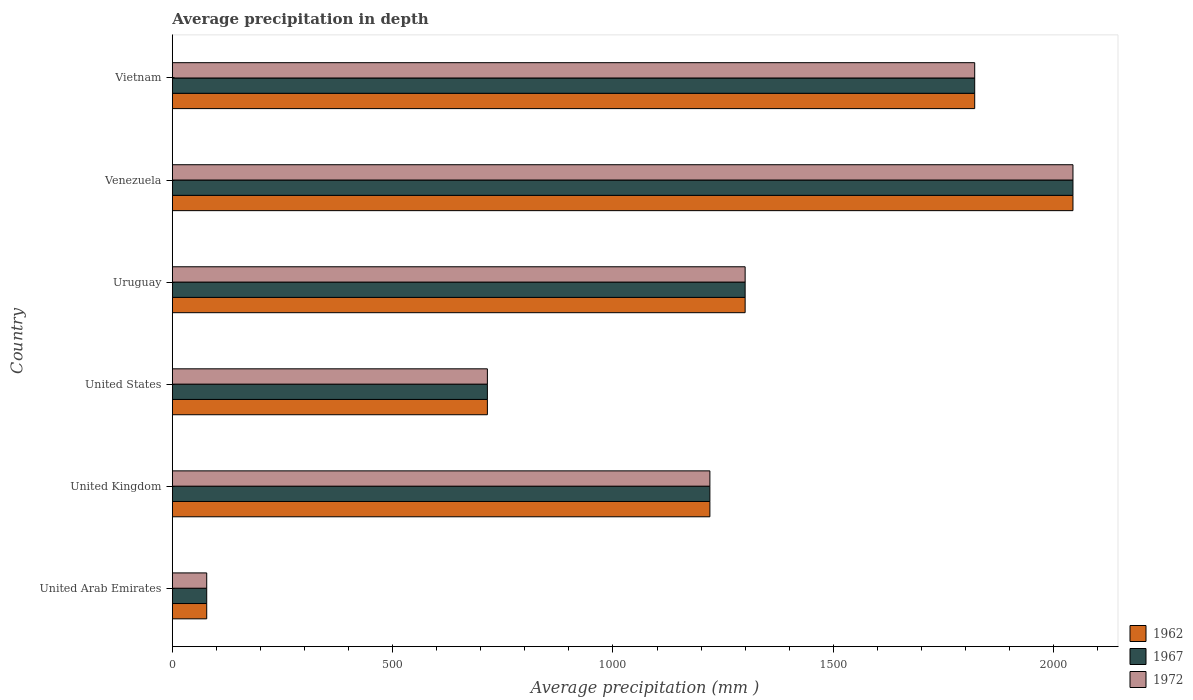How many different coloured bars are there?
Offer a terse response. 3. How many groups of bars are there?
Your response must be concise. 6. Are the number of bars on each tick of the Y-axis equal?
Provide a succinct answer. Yes. How many bars are there on the 4th tick from the top?
Your response must be concise. 3. What is the label of the 1st group of bars from the top?
Ensure brevity in your answer.  Vietnam. In how many cases, is the number of bars for a given country not equal to the number of legend labels?
Your answer should be very brief. 0. What is the average precipitation in 1962 in United Arab Emirates?
Offer a very short reply. 78. Across all countries, what is the maximum average precipitation in 1972?
Provide a succinct answer. 2044. Across all countries, what is the minimum average precipitation in 1962?
Provide a short and direct response. 78. In which country was the average precipitation in 1967 maximum?
Make the answer very short. Venezuela. In which country was the average precipitation in 1967 minimum?
Offer a terse response. United Arab Emirates. What is the total average precipitation in 1972 in the graph?
Your answer should be very brief. 7178. What is the difference between the average precipitation in 1972 in United Kingdom and that in Venezuela?
Provide a short and direct response. -824. What is the difference between the average precipitation in 1967 in United States and the average precipitation in 1962 in Uruguay?
Your answer should be very brief. -585. What is the average average precipitation in 1967 per country?
Provide a succinct answer. 1196.33. What is the difference between the average precipitation in 1967 and average precipitation in 1972 in United States?
Keep it short and to the point. 0. In how many countries, is the average precipitation in 1972 greater than 600 mm?
Your answer should be very brief. 5. What is the ratio of the average precipitation in 1967 in United Kingdom to that in United States?
Provide a succinct answer. 1.71. Is the difference between the average precipitation in 1967 in United States and Uruguay greater than the difference between the average precipitation in 1972 in United States and Uruguay?
Give a very brief answer. No. What is the difference between the highest and the second highest average precipitation in 1967?
Provide a succinct answer. 223. What is the difference between the highest and the lowest average precipitation in 1962?
Your answer should be compact. 1966. What does the 2nd bar from the bottom in United Kingdom represents?
Give a very brief answer. 1967. Are all the bars in the graph horizontal?
Offer a very short reply. Yes. What is the difference between two consecutive major ticks on the X-axis?
Give a very brief answer. 500. Are the values on the major ticks of X-axis written in scientific E-notation?
Your answer should be compact. No. Where does the legend appear in the graph?
Provide a short and direct response. Bottom right. How many legend labels are there?
Your answer should be compact. 3. What is the title of the graph?
Your answer should be compact. Average precipitation in depth. What is the label or title of the X-axis?
Provide a short and direct response. Average precipitation (mm ). What is the Average precipitation (mm ) in 1962 in United Arab Emirates?
Offer a very short reply. 78. What is the Average precipitation (mm ) of 1972 in United Arab Emirates?
Your response must be concise. 78. What is the Average precipitation (mm ) in 1962 in United Kingdom?
Make the answer very short. 1220. What is the Average precipitation (mm ) in 1967 in United Kingdom?
Your answer should be very brief. 1220. What is the Average precipitation (mm ) of 1972 in United Kingdom?
Offer a terse response. 1220. What is the Average precipitation (mm ) in 1962 in United States?
Offer a terse response. 715. What is the Average precipitation (mm ) in 1967 in United States?
Provide a succinct answer. 715. What is the Average precipitation (mm ) in 1972 in United States?
Your answer should be very brief. 715. What is the Average precipitation (mm ) of 1962 in Uruguay?
Your response must be concise. 1300. What is the Average precipitation (mm ) of 1967 in Uruguay?
Your response must be concise. 1300. What is the Average precipitation (mm ) in 1972 in Uruguay?
Make the answer very short. 1300. What is the Average precipitation (mm ) in 1962 in Venezuela?
Your answer should be compact. 2044. What is the Average precipitation (mm ) in 1967 in Venezuela?
Ensure brevity in your answer.  2044. What is the Average precipitation (mm ) in 1972 in Venezuela?
Provide a succinct answer. 2044. What is the Average precipitation (mm ) of 1962 in Vietnam?
Offer a terse response. 1821. What is the Average precipitation (mm ) in 1967 in Vietnam?
Offer a very short reply. 1821. What is the Average precipitation (mm ) in 1972 in Vietnam?
Ensure brevity in your answer.  1821. Across all countries, what is the maximum Average precipitation (mm ) of 1962?
Your response must be concise. 2044. Across all countries, what is the maximum Average precipitation (mm ) of 1967?
Ensure brevity in your answer.  2044. Across all countries, what is the maximum Average precipitation (mm ) in 1972?
Provide a succinct answer. 2044. Across all countries, what is the minimum Average precipitation (mm ) of 1962?
Provide a short and direct response. 78. Across all countries, what is the minimum Average precipitation (mm ) in 1972?
Offer a terse response. 78. What is the total Average precipitation (mm ) in 1962 in the graph?
Provide a succinct answer. 7178. What is the total Average precipitation (mm ) of 1967 in the graph?
Your answer should be very brief. 7178. What is the total Average precipitation (mm ) in 1972 in the graph?
Provide a succinct answer. 7178. What is the difference between the Average precipitation (mm ) of 1962 in United Arab Emirates and that in United Kingdom?
Give a very brief answer. -1142. What is the difference between the Average precipitation (mm ) of 1967 in United Arab Emirates and that in United Kingdom?
Keep it short and to the point. -1142. What is the difference between the Average precipitation (mm ) of 1972 in United Arab Emirates and that in United Kingdom?
Offer a very short reply. -1142. What is the difference between the Average precipitation (mm ) in 1962 in United Arab Emirates and that in United States?
Ensure brevity in your answer.  -637. What is the difference between the Average precipitation (mm ) of 1967 in United Arab Emirates and that in United States?
Keep it short and to the point. -637. What is the difference between the Average precipitation (mm ) of 1972 in United Arab Emirates and that in United States?
Your response must be concise. -637. What is the difference between the Average precipitation (mm ) in 1962 in United Arab Emirates and that in Uruguay?
Your response must be concise. -1222. What is the difference between the Average precipitation (mm ) of 1967 in United Arab Emirates and that in Uruguay?
Make the answer very short. -1222. What is the difference between the Average precipitation (mm ) of 1972 in United Arab Emirates and that in Uruguay?
Give a very brief answer. -1222. What is the difference between the Average precipitation (mm ) of 1962 in United Arab Emirates and that in Venezuela?
Keep it short and to the point. -1966. What is the difference between the Average precipitation (mm ) of 1967 in United Arab Emirates and that in Venezuela?
Provide a short and direct response. -1966. What is the difference between the Average precipitation (mm ) in 1972 in United Arab Emirates and that in Venezuela?
Your answer should be compact. -1966. What is the difference between the Average precipitation (mm ) in 1962 in United Arab Emirates and that in Vietnam?
Keep it short and to the point. -1743. What is the difference between the Average precipitation (mm ) of 1967 in United Arab Emirates and that in Vietnam?
Your answer should be very brief. -1743. What is the difference between the Average precipitation (mm ) of 1972 in United Arab Emirates and that in Vietnam?
Ensure brevity in your answer.  -1743. What is the difference between the Average precipitation (mm ) of 1962 in United Kingdom and that in United States?
Make the answer very short. 505. What is the difference between the Average precipitation (mm ) of 1967 in United Kingdom and that in United States?
Offer a very short reply. 505. What is the difference between the Average precipitation (mm ) in 1972 in United Kingdom and that in United States?
Ensure brevity in your answer.  505. What is the difference between the Average precipitation (mm ) of 1962 in United Kingdom and that in Uruguay?
Give a very brief answer. -80. What is the difference between the Average precipitation (mm ) in 1967 in United Kingdom and that in Uruguay?
Provide a succinct answer. -80. What is the difference between the Average precipitation (mm ) of 1972 in United Kingdom and that in Uruguay?
Provide a short and direct response. -80. What is the difference between the Average precipitation (mm ) of 1962 in United Kingdom and that in Venezuela?
Provide a short and direct response. -824. What is the difference between the Average precipitation (mm ) of 1967 in United Kingdom and that in Venezuela?
Give a very brief answer. -824. What is the difference between the Average precipitation (mm ) of 1972 in United Kingdom and that in Venezuela?
Provide a short and direct response. -824. What is the difference between the Average precipitation (mm ) in 1962 in United Kingdom and that in Vietnam?
Your response must be concise. -601. What is the difference between the Average precipitation (mm ) in 1967 in United Kingdom and that in Vietnam?
Offer a terse response. -601. What is the difference between the Average precipitation (mm ) of 1972 in United Kingdom and that in Vietnam?
Your answer should be very brief. -601. What is the difference between the Average precipitation (mm ) of 1962 in United States and that in Uruguay?
Your response must be concise. -585. What is the difference between the Average precipitation (mm ) in 1967 in United States and that in Uruguay?
Offer a very short reply. -585. What is the difference between the Average precipitation (mm ) of 1972 in United States and that in Uruguay?
Your answer should be very brief. -585. What is the difference between the Average precipitation (mm ) in 1962 in United States and that in Venezuela?
Provide a short and direct response. -1329. What is the difference between the Average precipitation (mm ) of 1967 in United States and that in Venezuela?
Make the answer very short. -1329. What is the difference between the Average precipitation (mm ) in 1972 in United States and that in Venezuela?
Your answer should be very brief. -1329. What is the difference between the Average precipitation (mm ) of 1962 in United States and that in Vietnam?
Offer a terse response. -1106. What is the difference between the Average precipitation (mm ) in 1967 in United States and that in Vietnam?
Make the answer very short. -1106. What is the difference between the Average precipitation (mm ) of 1972 in United States and that in Vietnam?
Provide a short and direct response. -1106. What is the difference between the Average precipitation (mm ) in 1962 in Uruguay and that in Venezuela?
Ensure brevity in your answer.  -744. What is the difference between the Average precipitation (mm ) in 1967 in Uruguay and that in Venezuela?
Ensure brevity in your answer.  -744. What is the difference between the Average precipitation (mm ) in 1972 in Uruguay and that in Venezuela?
Ensure brevity in your answer.  -744. What is the difference between the Average precipitation (mm ) of 1962 in Uruguay and that in Vietnam?
Provide a succinct answer. -521. What is the difference between the Average precipitation (mm ) of 1967 in Uruguay and that in Vietnam?
Keep it short and to the point. -521. What is the difference between the Average precipitation (mm ) of 1972 in Uruguay and that in Vietnam?
Your answer should be very brief. -521. What is the difference between the Average precipitation (mm ) of 1962 in Venezuela and that in Vietnam?
Offer a very short reply. 223. What is the difference between the Average precipitation (mm ) of 1967 in Venezuela and that in Vietnam?
Make the answer very short. 223. What is the difference between the Average precipitation (mm ) of 1972 in Venezuela and that in Vietnam?
Your response must be concise. 223. What is the difference between the Average precipitation (mm ) in 1962 in United Arab Emirates and the Average precipitation (mm ) in 1967 in United Kingdom?
Your response must be concise. -1142. What is the difference between the Average precipitation (mm ) of 1962 in United Arab Emirates and the Average precipitation (mm ) of 1972 in United Kingdom?
Keep it short and to the point. -1142. What is the difference between the Average precipitation (mm ) in 1967 in United Arab Emirates and the Average precipitation (mm ) in 1972 in United Kingdom?
Provide a short and direct response. -1142. What is the difference between the Average precipitation (mm ) in 1962 in United Arab Emirates and the Average precipitation (mm ) in 1967 in United States?
Your answer should be compact. -637. What is the difference between the Average precipitation (mm ) of 1962 in United Arab Emirates and the Average precipitation (mm ) of 1972 in United States?
Give a very brief answer. -637. What is the difference between the Average precipitation (mm ) in 1967 in United Arab Emirates and the Average precipitation (mm ) in 1972 in United States?
Make the answer very short. -637. What is the difference between the Average precipitation (mm ) in 1962 in United Arab Emirates and the Average precipitation (mm ) in 1967 in Uruguay?
Your answer should be very brief. -1222. What is the difference between the Average precipitation (mm ) in 1962 in United Arab Emirates and the Average precipitation (mm ) in 1972 in Uruguay?
Provide a succinct answer. -1222. What is the difference between the Average precipitation (mm ) in 1967 in United Arab Emirates and the Average precipitation (mm ) in 1972 in Uruguay?
Your answer should be compact. -1222. What is the difference between the Average precipitation (mm ) in 1962 in United Arab Emirates and the Average precipitation (mm ) in 1967 in Venezuela?
Your answer should be compact. -1966. What is the difference between the Average precipitation (mm ) in 1962 in United Arab Emirates and the Average precipitation (mm ) in 1972 in Venezuela?
Provide a short and direct response. -1966. What is the difference between the Average precipitation (mm ) of 1967 in United Arab Emirates and the Average precipitation (mm ) of 1972 in Venezuela?
Offer a very short reply. -1966. What is the difference between the Average precipitation (mm ) in 1962 in United Arab Emirates and the Average precipitation (mm ) in 1967 in Vietnam?
Make the answer very short. -1743. What is the difference between the Average precipitation (mm ) of 1962 in United Arab Emirates and the Average precipitation (mm ) of 1972 in Vietnam?
Make the answer very short. -1743. What is the difference between the Average precipitation (mm ) in 1967 in United Arab Emirates and the Average precipitation (mm ) in 1972 in Vietnam?
Make the answer very short. -1743. What is the difference between the Average precipitation (mm ) in 1962 in United Kingdom and the Average precipitation (mm ) in 1967 in United States?
Ensure brevity in your answer.  505. What is the difference between the Average precipitation (mm ) of 1962 in United Kingdom and the Average precipitation (mm ) of 1972 in United States?
Make the answer very short. 505. What is the difference between the Average precipitation (mm ) of 1967 in United Kingdom and the Average precipitation (mm ) of 1972 in United States?
Make the answer very short. 505. What is the difference between the Average precipitation (mm ) in 1962 in United Kingdom and the Average precipitation (mm ) in 1967 in Uruguay?
Your response must be concise. -80. What is the difference between the Average precipitation (mm ) in 1962 in United Kingdom and the Average precipitation (mm ) in 1972 in Uruguay?
Give a very brief answer. -80. What is the difference between the Average precipitation (mm ) of 1967 in United Kingdom and the Average precipitation (mm ) of 1972 in Uruguay?
Provide a short and direct response. -80. What is the difference between the Average precipitation (mm ) of 1962 in United Kingdom and the Average precipitation (mm ) of 1967 in Venezuela?
Ensure brevity in your answer.  -824. What is the difference between the Average precipitation (mm ) in 1962 in United Kingdom and the Average precipitation (mm ) in 1972 in Venezuela?
Keep it short and to the point. -824. What is the difference between the Average precipitation (mm ) in 1967 in United Kingdom and the Average precipitation (mm ) in 1972 in Venezuela?
Provide a short and direct response. -824. What is the difference between the Average precipitation (mm ) in 1962 in United Kingdom and the Average precipitation (mm ) in 1967 in Vietnam?
Make the answer very short. -601. What is the difference between the Average precipitation (mm ) in 1962 in United Kingdom and the Average precipitation (mm ) in 1972 in Vietnam?
Offer a very short reply. -601. What is the difference between the Average precipitation (mm ) in 1967 in United Kingdom and the Average precipitation (mm ) in 1972 in Vietnam?
Ensure brevity in your answer.  -601. What is the difference between the Average precipitation (mm ) of 1962 in United States and the Average precipitation (mm ) of 1967 in Uruguay?
Offer a terse response. -585. What is the difference between the Average precipitation (mm ) of 1962 in United States and the Average precipitation (mm ) of 1972 in Uruguay?
Provide a succinct answer. -585. What is the difference between the Average precipitation (mm ) in 1967 in United States and the Average precipitation (mm ) in 1972 in Uruguay?
Your response must be concise. -585. What is the difference between the Average precipitation (mm ) in 1962 in United States and the Average precipitation (mm ) in 1967 in Venezuela?
Give a very brief answer. -1329. What is the difference between the Average precipitation (mm ) in 1962 in United States and the Average precipitation (mm ) in 1972 in Venezuela?
Your answer should be very brief. -1329. What is the difference between the Average precipitation (mm ) in 1967 in United States and the Average precipitation (mm ) in 1972 in Venezuela?
Offer a very short reply. -1329. What is the difference between the Average precipitation (mm ) of 1962 in United States and the Average precipitation (mm ) of 1967 in Vietnam?
Ensure brevity in your answer.  -1106. What is the difference between the Average precipitation (mm ) in 1962 in United States and the Average precipitation (mm ) in 1972 in Vietnam?
Your response must be concise. -1106. What is the difference between the Average precipitation (mm ) of 1967 in United States and the Average precipitation (mm ) of 1972 in Vietnam?
Give a very brief answer. -1106. What is the difference between the Average precipitation (mm ) in 1962 in Uruguay and the Average precipitation (mm ) in 1967 in Venezuela?
Your answer should be compact. -744. What is the difference between the Average precipitation (mm ) in 1962 in Uruguay and the Average precipitation (mm ) in 1972 in Venezuela?
Your answer should be very brief. -744. What is the difference between the Average precipitation (mm ) of 1967 in Uruguay and the Average precipitation (mm ) of 1972 in Venezuela?
Provide a short and direct response. -744. What is the difference between the Average precipitation (mm ) of 1962 in Uruguay and the Average precipitation (mm ) of 1967 in Vietnam?
Offer a terse response. -521. What is the difference between the Average precipitation (mm ) in 1962 in Uruguay and the Average precipitation (mm ) in 1972 in Vietnam?
Keep it short and to the point. -521. What is the difference between the Average precipitation (mm ) in 1967 in Uruguay and the Average precipitation (mm ) in 1972 in Vietnam?
Provide a succinct answer. -521. What is the difference between the Average precipitation (mm ) in 1962 in Venezuela and the Average precipitation (mm ) in 1967 in Vietnam?
Your answer should be compact. 223. What is the difference between the Average precipitation (mm ) of 1962 in Venezuela and the Average precipitation (mm ) of 1972 in Vietnam?
Your answer should be very brief. 223. What is the difference between the Average precipitation (mm ) in 1967 in Venezuela and the Average precipitation (mm ) in 1972 in Vietnam?
Offer a very short reply. 223. What is the average Average precipitation (mm ) of 1962 per country?
Your response must be concise. 1196.33. What is the average Average precipitation (mm ) in 1967 per country?
Your response must be concise. 1196.33. What is the average Average precipitation (mm ) in 1972 per country?
Offer a terse response. 1196.33. What is the difference between the Average precipitation (mm ) in 1962 and Average precipitation (mm ) in 1972 in United Arab Emirates?
Offer a terse response. 0. What is the difference between the Average precipitation (mm ) in 1967 and Average precipitation (mm ) in 1972 in United Arab Emirates?
Give a very brief answer. 0. What is the difference between the Average precipitation (mm ) in 1962 and Average precipitation (mm ) in 1967 in United Kingdom?
Offer a terse response. 0. What is the difference between the Average precipitation (mm ) in 1967 and Average precipitation (mm ) in 1972 in United Kingdom?
Offer a terse response. 0. What is the difference between the Average precipitation (mm ) of 1967 and Average precipitation (mm ) of 1972 in United States?
Your answer should be compact. 0. What is the difference between the Average precipitation (mm ) in 1962 and Average precipitation (mm ) in 1967 in Uruguay?
Provide a short and direct response. 0. What is the difference between the Average precipitation (mm ) of 1967 and Average precipitation (mm ) of 1972 in Uruguay?
Make the answer very short. 0. What is the difference between the Average precipitation (mm ) of 1962 and Average precipitation (mm ) of 1967 in Venezuela?
Provide a short and direct response. 0. What is the difference between the Average precipitation (mm ) of 1967 and Average precipitation (mm ) of 1972 in Venezuela?
Your answer should be very brief. 0. What is the difference between the Average precipitation (mm ) in 1962 and Average precipitation (mm ) in 1967 in Vietnam?
Your answer should be compact. 0. What is the ratio of the Average precipitation (mm ) of 1962 in United Arab Emirates to that in United Kingdom?
Ensure brevity in your answer.  0.06. What is the ratio of the Average precipitation (mm ) in 1967 in United Arab Emirates to that in United Kingdom?
Provide a succinct answer. 0.06. What is the ratio of the Average precipitation (mm ) of 1972 in United Arab Emirates to that in United Kingdom?
Keep it short and to the point. 0.06. What is the ratio of the Average precipitation (mm ) in 1962 in United Arab Emirates to that in United States?
Ensure brevity in your answer.  0.11. What is the ratio of the Average precipitation (mm ) in 1967 in United Arab Emirates to that in United States?
Keep it short and to the point. 0.11. What is the ratio of the Average precipitation (mm ) of 1972 in United Arab Emirates to that in United States?
Your answer should be very brief. 0.11. What is the ratio of the Average precipitation (mm ) in 1962 in United Arab Emirates to that in Uruguay?
Make the answer very short. 0.06. What is the ratio of the Average precipitation (mm ) of 1967 in United Arab Emirates to that in Uruguay?
Your answer should be very brief. 0.06. What is the ratio of the Average precipitation (mm ) in 1962 in United Arab Emirates to that in Venezuela?
Your answer should be very brief. 0.04. What is the ratio of the Average precipitation (mm ) in 1967 in United Arab Emirates to that in Venezuela?
Provide a succinct answer. 0.04. What is the ratio of the Average precipitation (mm ) of 1972 in United Arab Emirates to that in Venezuela?
Provide a succinct answer. 0.04. What is the ratio of the Average precipitation (mm ) of 1962 in United Arab Emirates to that in Vietnam?
Ensure brevity in your answer.  0.04. What is the ratio of the Average precipitation (mm ) of 1967 in United Arab Emirates to that in Vietnam?
Ensure brevity in your answer.  0.04. What is the ratio of the Average precipitation (mm ) of 1972 in United Arab Emirates to that in Vietnam?
Your answer should be very brief. 0.04. What is the ratio of the Average precipitation (mm ) in 1962 in United Kingdom to that in United States?
Offer a terse response. 1.71. What is the ratio of the Average precipitation (mm ) of 1967 in United Kingdom to that in United States?
Ensure brevity in your answer.  1.71. What is the ratio of the Average precipitation (mm ) in 1972 in United Kingdom to that in United States?
Offer a terse response. 1.71. What is the ratio of the Average precipitation (mm ) in 1962 in United Kingdom to that in Uruguay?
Give a very brief answer. 0.94. What is the ratio of the Average precipitation (mm ) of 1967 in United Kingdom to that in Uruguay?
Provide a succinct answer. 0.94. What is the ratio of the Average precipitation (mm ) of 1972 in United Kingdom to that in Uruguay?
Provide a short and direct response. 0.94. What is the ratio of the Average precipitation (mm ) of 1962 in United Kingdom to that in Venezuela?
Your response must be concise. 0.6. What is the ratio of the Average precipitation (mm ) of 1967 in United Kingdom to that in Venezuela?
Ensure brevity in your answer.  0.6. What is the ratio of the Average precipitation (mm ) in 1972 in United Kingdom to that in Venezuela?
Offer a terse response. 0.6. What is the ratio of the Average precipitation (mm ) in 1962 in United Kingdom to that in Vietnam?
Give a very brief answer. 0.67. What is the ratio of the Average precipitation (mm ) of 1967 in United Kingdom to that in Vietnam?
Make the answer very short. 0.67. What is the ratio of the Average precipitation (mm ) in 1972 in United Kingdom to that in Vietnam?
Offer a very short reply. 0.67. What is the ratio of the Average precipitation (mm ) in 1962 in United States to that in Uruguay?
Your answer should be very brief. 0.55. What is the ratio of the Average precipitation (mm ) in 1967 in United States to that in Uruguay?
Offer a terse response. 0.55. What is the ratio of the Average precipitation (mm ) of 1972 in United States to that in Uruguay?
Provide a succinct answer. 0.55. What is the ratio of the Average precipitation (mm ) of 1962 in United States to that in Venezuela?
Provide a short and direct response. 0.35. What is the ratio of the Average precipitation (mm ) of 1967 in United States to that in Venezuela?
Make the answer very short. 0.35. What is the ratio of the Average precipitation (mm ) of 1972 in United States to that in Venezuela?
Provide a succinct answer. 0.35. What is the ratio of the Average precipitation (mm ) in 1962 in United States to that in Vietnam?
Provide a succinct answer. 0.39. What is the ratio of the Average precipitation (mm ) in 1967 in United States to that in Vietnam?
Offer a terse response. 0.39. What is the ratio of the Average precipitation (mm ) of 1972 in United States to that in Vietnam?
Your answer should be compact. 0.39. What is the ratio of the Average precipitation (mm ) in 1962 in Uruguay to that in Venezuela?
Make the answer very short. 0.64. What is the ratio of the Average precipitation (mm ) of 1967 in Uruguay to that in Venezuela?
Ensure brevity in your answer.  0.64. What is the ratio of the Average precipitation (mm ) of 1972 in Uruguay to that in Venezuela?
Ensure brevity in your answer.  0.64. What is the ratio of the Average precipitation (mm ) in 1962 in Uruguay to that in Vietnam?
Your response must be concise. 0.71. What is the ratio of the Average precipitation (mm ) of 1967 in Uruguay to that in Vietnam?
Provide a short and direct response. 0.71. What is the ratio of the Average precipitation (mm ) in 1972 in Uruguay to that in Vietnam?
Provide a short and direct response. 0.71. What is the ratio of the Average precipitation (mm ) in 1962 in Venezuela to that in Vietnam?
Your response must be concise. 1.12. What is the ratio of the Average precipitation (mm ) in 1967 in Venezuela to that in Vietnam?
Give a very brief answer. 1.12. What is the ratio of the Average precipitation (mm ) of 1972 in Venezuela to that in Vietnam?
Your answer should be very brief. 1.12. What is the difference between the highest and the second highest Average precipitation (mm ) of 1962?
Make the answer very short. 223. What is the difference between the highest and the second highest Average precipitation (mm ) in 1967?
Your response must be concise. 223. What is the difference between the highest and the second highest Average precipitation (mm ) in 1972?
Your response must be concise. 223. What is the difference between the highest and the lowest Average precipitation (mm ) of 1962?
Provide a short and direct response. 1966. What is the difference between the highest and the lowest Average precipitation (mm ) of 1967?
Your answer should be compact. 1966. What is the difference between the highest and the lowest Average precipitation (mm ) in 1972?
Give a very brief answer. 1966. 